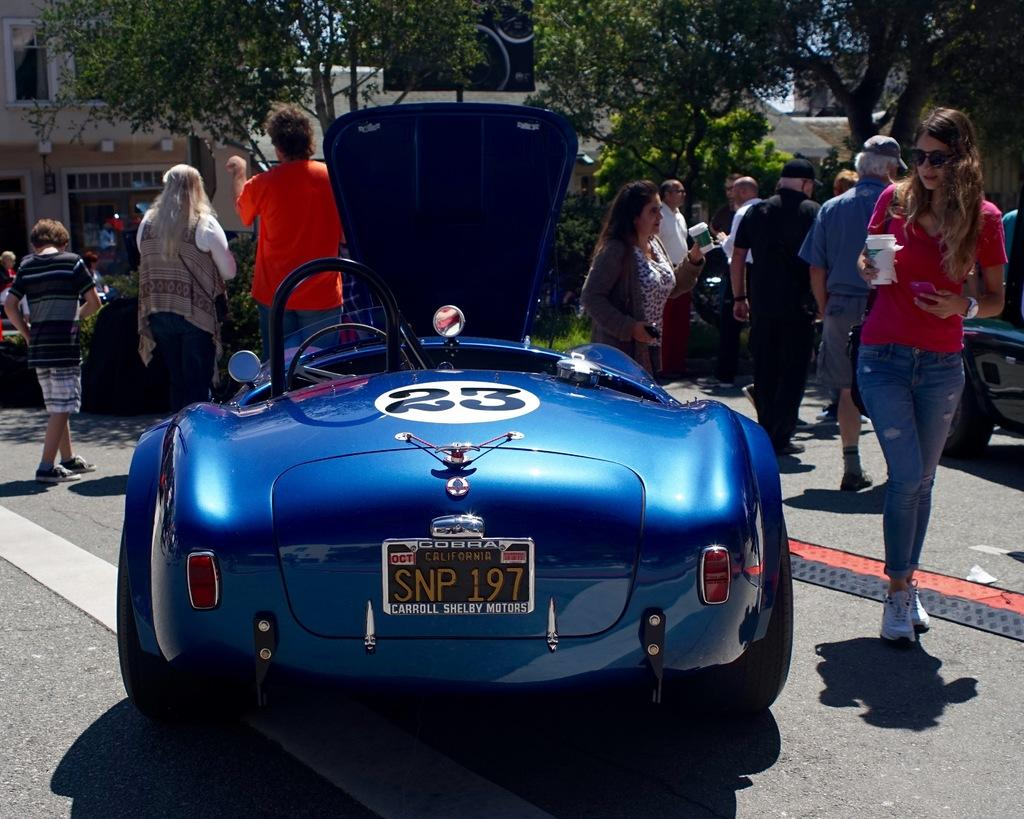What types of living beings can be seen in the image? There are people in the image. What else can be seen in the image besides people? There are vehicles, buildings, trees, and plants visible in the image. What is the surface on which the people, vehicles, and other objects are situated? The ground is visible in the image. What type of organization is being held in the image? There is no indication of an organization or event taking place in the image. 